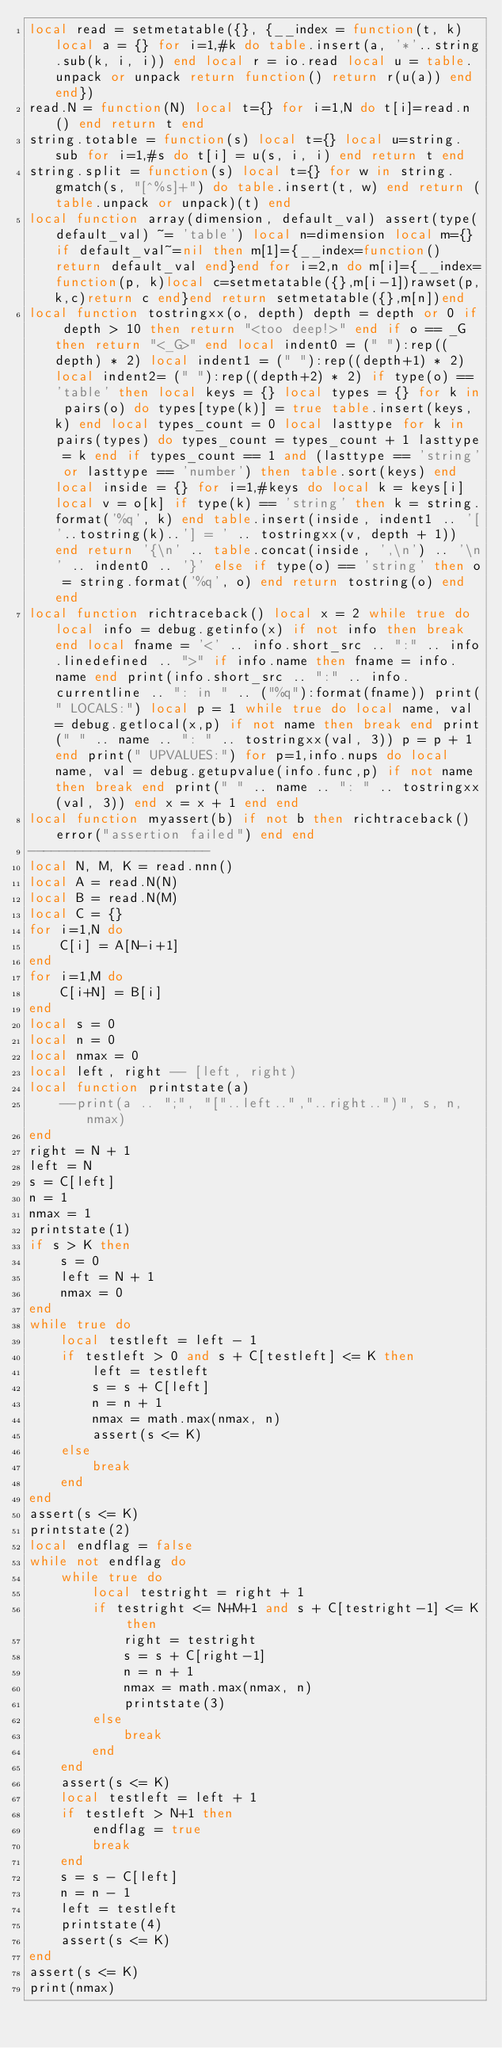<code> <loc_0><loc_0><loc_500><loc_500><_Lua_>local read = setmetatable({}, {__index = function(t, k) local a = {} for i=1,#k do table.insert(a, '*'..string.sub(k, i, i)) end local r = io.read local u = table.unpack or unpack return function() return r(u(a)) end end})
read.N = function(N) local t={} for i=1,N do t[i]=read.n() end return t end
string.totable = function(s) local t={} local u=string.sub for i=1,#s do t[i] = u(s, i, i) end return t end
string.split = function(s) local t={} for w in string.gmatch(s, "[^%s]+") do table.insert(t, w) end return (table.unpack or unpack)(t) end
local function array(dimension, default_val) assert(type(default_val) ~= 'table') local n=dimension local m={}if default_val~=nil then m[1]={__index=function()return default_val end}end for i=2,n do m[i]={__index=function(p, k)local c=setmetatable({},m[i-1])rawset(p,k,c)return c end}end return setmetatable({},m[n])end
local function tostringxx(o, depth) depth = depth or 0 if depth > 10 then return "<too deep!>" end if o == _G then return "<_G>" end local indent0 = (" "):rep((depth) * 2) local indent1 = (" "):rep((depth+1) * 2) local indent2= (" "):rep((depth+2) * 2) if type(o) == 'table' then local keys = {} local types = {} for k in pairs(o) do types[type(k)] = true table.insert(keys, k) end local types_count = 0 local lasttype for k in pairs(types) do types_count = types_count + 1 lasttype = k end if types_count == 1 and (lasttype == 'string' or lasttype == 'number') then table.sort(keys) end local inside = {} for i=1,#keys do local k = keys[i] local v = o[k] if type(k) == 'string' then k = string.format('%q', k) end table.insert(inside, indent1 .. '['..tostring(k)..'] = ' .. tostringxx(v, depth + 1)) end return '{\n' .. table.concat(inside, ',\n') .. '\n' .. indent0 .. '}' else if type(o) == 'string' then o = string.format('%q', o) end return tostring(o) end end
local function richtraceback() local x = 2 while true do local info = debug.getinfo(x) if not info then break end local fname = '<' .. info.short_src .. ":" .. info.linedefined .. ">" if info.name then fname = info.name end print(info.short_src .. ":" .. info.currentline .. ": in " .. ("%q"):format(fname)) print(" LOCALS:") local p = 1 while true do local name, val = debug.getlocal(x,p) if not name then break end print(" " .. name .. ": " .. tostringxx(val, 3)) p = p + 1 end print(" UPVALUES:") for p=1,info.nups do local name, val = debug.getupvalue(info.func,p) if not name then break end print(" " .. name .. ": " .. tostringxx(val, 3)) end x = x + 1 end end
local function myassert(b) if not b then richtraceback() error("assertion failed") end end 
-----------------------
local N, M, K = read.nnn()
local A = read.N(N)
local B = read.N(M)
local C = {}
for i=1,N do
    C[i] = A[N-i+1]
end
for i=1,M do
    C[i+N] = B[i]
end
local s = 0
local n = 0
local nmax = 0
local left, right -- [left, right)
local function printstate(a)
    --print(a .. ";", "["..left..","..right..")", s, n, nmax)
end
right = N + 1
left = N
s = C[left]
n = 1
nmax = 1
printstate(1)
if s > K then
    s = 0
    left = N + 1
    nmax = 0
end
while true do
    local testleft = left - 1
    if testleft > 0 and s + C[testleft] <= K then
        left = testleft
        s = s + C[left]
        n = n + 1
        nmax = math.max(nmax, n)
        assert(s <= K)
    else
        break
    end
end
assert(s <= K)
printstate(2)
local endflag = false
while not endflag do
    while true do
        local testright = right + 1
        if testright <= N+M+1 and s + C[testright-1] <= K then
            right = testright
            s = s + C[right-1]
            n = n + 1
            nmax = math.max(nmax, n)
            printstate(3)
        else
            break
        end
    end
    assert(s <= K)
    local testleft = left + 1
    if testleft > N+1 then
        endflag = true
        break
    end
    s = s - C[left]
    n = n - 1
    left = testleft
    printstate(4)
    assert(s <= K)
end
assert(s <= K)
print(nmax)</code> 